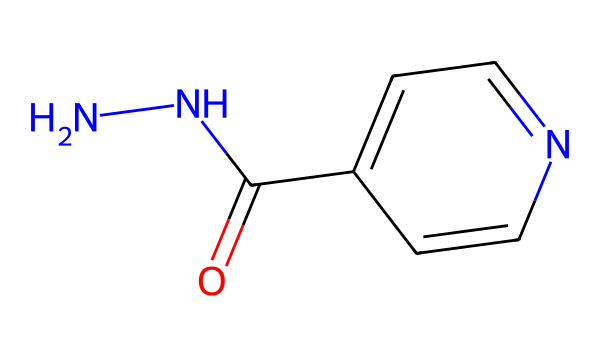What is the chemical name of this structure? The SMILES notation denotes the molecular structure of isoniazid, which includes a hydrazine functional group (N-N) attached to a pyridine ring with an acyl functional group.
Answer: isoniazid How many nitrogen atoms are present in isoniazid? In the SMILES representation, there are two nitrogen atoms indicated by "NN". This is characteristic of hydrazines, which always contain two nitrogen atoms in their structure.
Answer: 2 What type of bond connects the nitrogen atoms in hydrazines? The two nitrogen atoms in isoniazid are connected by a single bond as represented in the SMILES with "NN". This is typical for hydrazine compounds where a single N-N bond characterizes their structure.
Answer: single bond What is the functional group present in isoniazid? The acyl group (C(=O)) seen in the chemical structure is a key functional group that defines isoniazid. It is attached to the ring structure and indicates its role in antibacterial activity.
Answer: acyl group How many aromatic rings are present in isoniazid? The chemical structure includes one aromatic ring, denoted by "c1ccncc1" in the SMILES. This signifies a pyridine-like structure which is part of the overall molecule.
Answer: 1 What class of compounds does isoniazid belong to based on its structure? The presence of the hydrazine functional group (NN) in isoniazid places it in the class of hydrazines, which are known for their roles in medicinal chemistry and as antituberculosis agents.
Answer: hydrazines What element is immediately bonded to the carbon in the acyl group? The oxygen atom is indicated in the SMILES representation by the "O" in "C(=O)", which shows that it is double-bonded to the carbon in the functional acyl group.
Answer: oxygen 